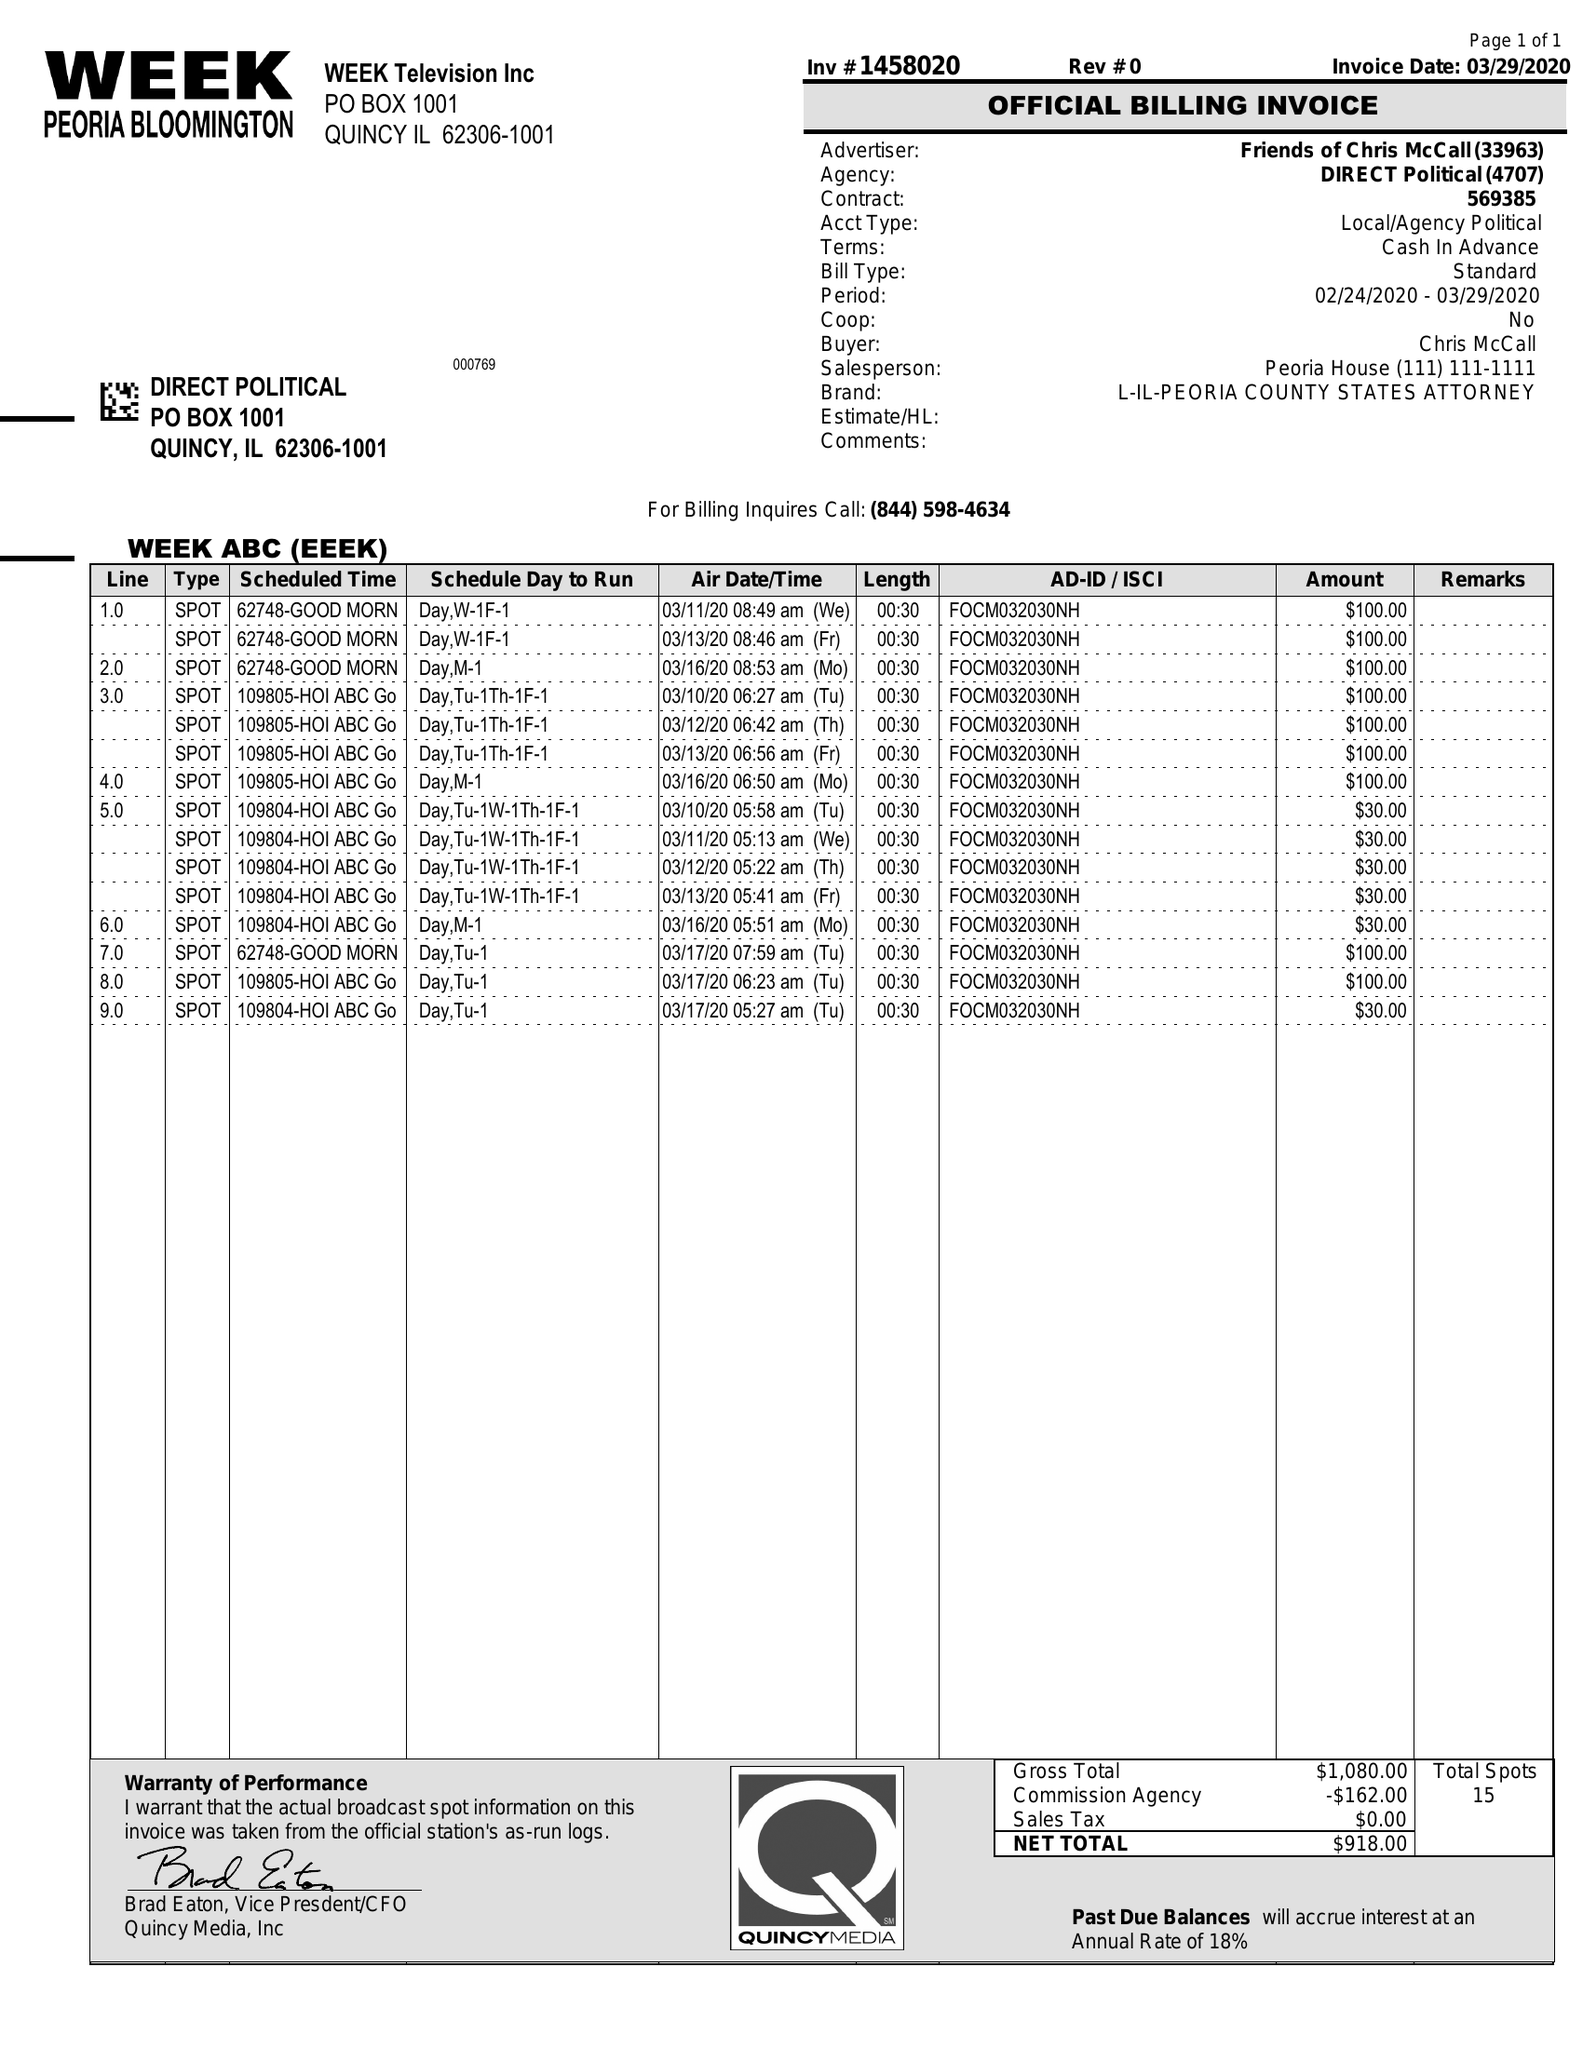What is the value for the advertiser?
Answer the question using a single word or phrase. FRIENDS OF CHRIS MCCALL 